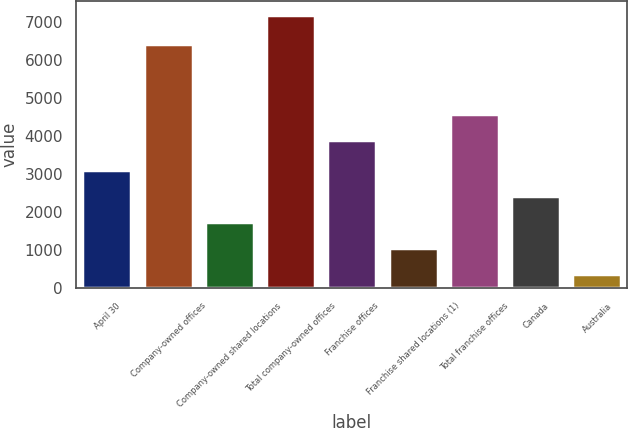Convert chart to OTSL. <chart><loc_0><loc_0><loc_500><loc_500><bar_chart><fcel>April 30<fcel>Company-owned offices<fcel>Company-owned shared locations<fcel>Total company-owned offices<fcel>Franchise offices<fcel>Franchise shared locations (1)<fcel>Total franchise offices<fcel>Canada<fcel>Australia<nl><fcel>3100.8<fcel>6431<fcel>1737.4<fcel>7191<fcel>3909<fcel>1055.7<fcel>4590.7<fcel>2419.1<fcel>374<nl></chart> 